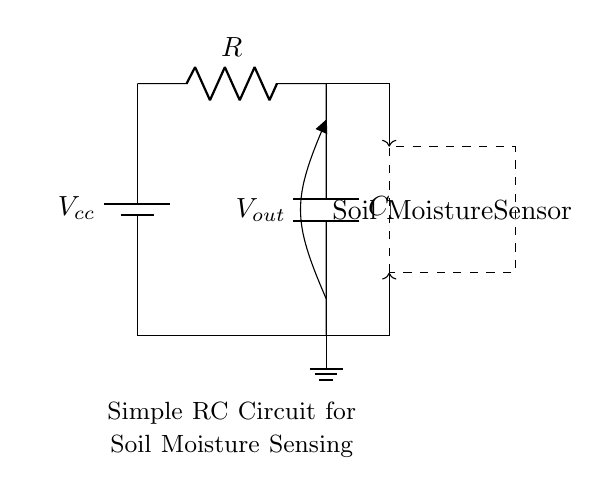What component generates the voltage in this circuit? The component that generates the voltage in this circuit is the battery, marked as Vcc, which supplies the necessary power for the operation of the circuit components.
Answer: battery What is the function of the resistor in this RC circuit? The function of the resistor is to limit the current that flows through the circuit and work with the capacitor to form an RC time constant, which affects how quickly the capacitor charges and discharges.
Answer: limit current What does the capacitor represent in this circuit? The capacitor represents a component that stores electrical energy in the form of an electric field when charge is applied to it; it is crucial for smoothing out voltage fluctuations from the sensor's output.
Answer: energy storage How does the output voltage relate to the capacitor's charge? The output voltage, Vout, at the capacitor's terminals depends on the charge stored in the capacitor, which changes as the moisture level alters how quickly the capacitor charges and discharges related to the sensor's readings.
Answer: it varies with charge What is the purpose of the soil moisture sensor in the circuit? The purpose of the soil moisture sensor is to detect the moisture level in the soil and send signals to the capacitor, influencing the output voltage based on the moisture present.
Answer: detect moisture 